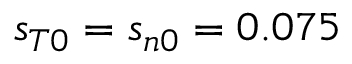<formula> <loc_0><loc_0><loc_500><loc_500>s _ { T 0 } = s _ { n 0 } = 0 . 0 7 5</formula> 